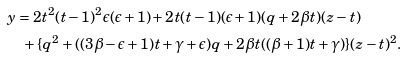Convert formula to latex. <formula><loc_0><loc_0><loc_500><loc_500>& y = 2 t ^ { 2 } ( t - 1 ) ^ { 2 } \epsilon ( \epsilon + 1 ) + 2 t ( t - 1 ) ( \epsilon + 1 ) ( q + 2 \beta t ) ( z - t ) \\ & \quad + \{ q ^ { 2 } + ( ( 3 \beta - \epsilon + 1 ) t + \gamma + \epsilon ) q + 2 \beta t ( ( \beta + 1 ) t + \gamma ) \} ( z - t ) ^ { 2 } .</formula> 